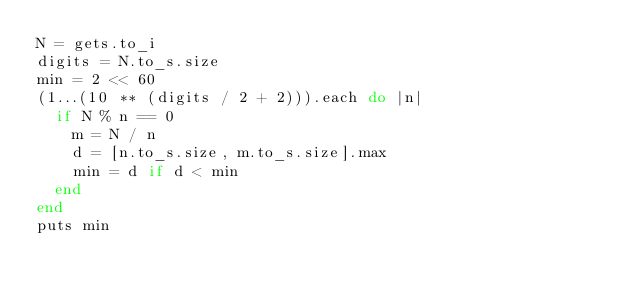Convert code to text. <code><loc_0><loc_0><loc_500><loc_500><_Ruby_>N = gets.to_i
digits = N.to_s.size
min = 2 << 60
(1...(10 ** (digits / 2 + 2))).each do |n|
  if N % n == 0
    m = N / n
    d = [n.to_s.size, m.to_s.size].max
    min = d if d < min
  end
end
puts min
</code> 